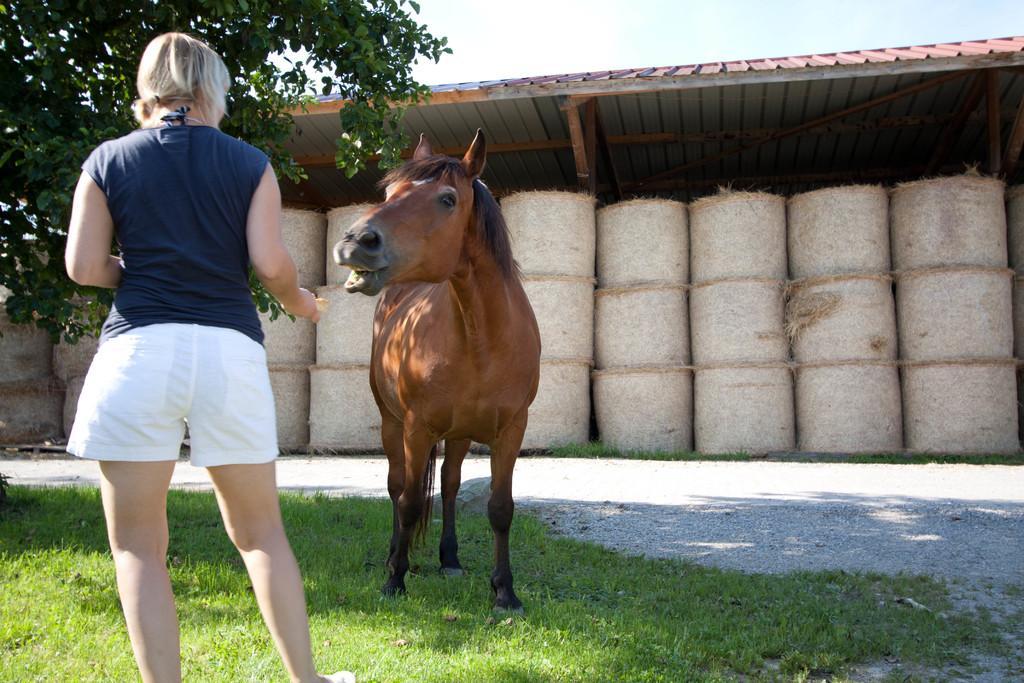Describe this image in one or two sentences. In this picture there is a woman standing on the grass and there is horse standing on the grass. At the back there are grass rolls under the shed. At the top there is sky. On the left side of the image there is a tree. At the bottom there is grass. 